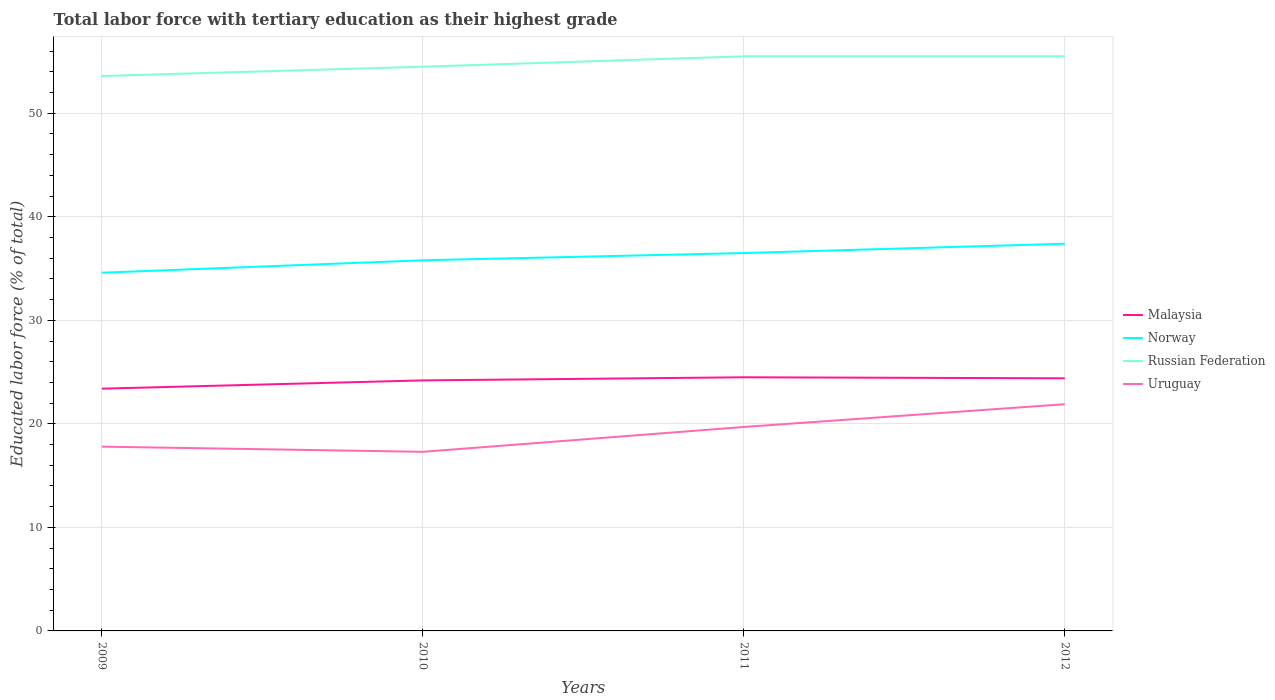Across all years, what is the maximum percentage of male labor force with tertiary education in Norway?
Give a very brief answer. 34.6. In which year was the percentage of male labor force with tertiary education in Malaysia maximum?
Offer a terse response. 2009. What is the total percentage of male labor force with tertiary education in Russian Federation in the graph?
Provide a short and direct response. 0. What is the difference between the highest and the second highest percentage of male labor force with tertiary education in Uruguay?
Offer a terse response. 4.6. How many lines are there?
Offer a very short reply. 4. How many years are there in the graph?
Provide a short and direct response. 4. What is the difference between two consecutive major ticks on the Y-axis?
Your answer should be very brief. 10. Are the values on the major ticks of Y-axis written in scientific E-notation?
Provide a short and direct response. No. Does the graph contain any zero values?
Your answer should be very brief. No. Does the graph contain grids?
Offer a terse response. Yes. Where does the legend appear in the graph?
Your response must be concise. Center right. How many legend labels are there?
Provide a short and direct response. 4. What is the title of the graph?
Your answer should be compact. Total labor force with tertiary education as their highest grade. What is the label or title of the Y-axis?
Make the answer very short. Educated labor force (% of total). What is the Educated labor force (% of total) of Malaysia in 2009?
Keep it short and to the point. 23.4. What is the Educated labor force (% of total) of Norway in 2009?
Offer a terse response. 34.6. What is the Educated labor force (% of total) of Russian Federation in 2009?
Make the answer very short. 53.6. What is the Educated labor force (% of total) in Uruguay in 2009?
Offer a very short reply. 17.8. What is the Educated labor force (% of total) of Malaysia in 2010?
Offer a very short reply. 24.2. What is the Educated labor force (% of total) in Norway in 2010?
Make the answer very short. 35.8. What is the Educated labor force (% of total) in Russian Federation in 2010?
Your response must be concise. 54.5. What is the Educated labor force (% of total) of Uruguay in 2010?
Offer a terse response. 17.3. What is the Educated labor force (% of total) of Malaysia in 2011?
Make the answer very short. 24.5. What is the Educated labor force (% of total) in Norway in 2011?
Make the answer very short. 36.5. What is the Educated labor force (% of total) in Russian Federation in 2011?
Your answer should be compact. 55.5. What is the Educated labor force (% of total) of Uruguay in 2011?
Make the answer very short. 19.7. What is the Educated labor force (% of total) in Malaysia in 2012?
Your response must be concise. 24.4. What is the Educated labor force (% of total) of Norway in 2012?
Provide a short and direct response. 37.4. What is the Educated labor force (% of total) in Russian Federation in 2012?
Make the answer very short. 55.5. What is the Educated labor force (% of total) of Uruguay in 2012?
Offer a terse response. 21.9. Across all years, what is the maximum Educated labor force (% of total) in Malaysia?
Offer a terse response. 24.5. Across all years, what is the maximum Educated labor force (% of total) of Norway?
Keep it short and to the point. 37.4. Across all years, what is the maximum Educated labor force (% of total) in Russian Federation?
Ensure brevity in your answer.  55.5. Across all years, what is the maximum Educated labor force (% of total) of Uruguay?
Your answer should be very brief. 21.9. Across all years, what is the minimum Educated labor force (% of total) in Malaysia?
Give a very brief answer. 23.4. Across all years, what is the minimum Educated labor force (% of total) of Norway?
Provide a succinct answer. 34.6. Across all years, what is the minimum Educated labor force (% of total) in Russian Federation?
Your answer should be compact. 53.6. Across all years, what is the minimum Educated labor force (% of total) in Uruguay?
Provide a succinct answer. 17.3. What is the total Educated labor force (% of total) of Malaysia in the graph?
Your answer should be very brief. 96.5. What is the total Educated labor force (% of total) in Norway in the graph?
Provide a succinct answer. 144.3. What is the total Educated labor force (% of total) of Russian Federation in the graph?
Your answer should be very brief. 219.1. What is the total Educated labor force (% of total) of Uruguay in the graph?
Provide a succinct answer. 76.7. What is the difference between the Educated labor force (% of total) in Russian Federation in 2009 and that in 2010?
Offer a very short reply. -0.9. What is the difference between the Educated labor force (% of total) of Uruguay in 2009 and that in 2010?
Offer a terse response. 0.5. What is the difference between the Educated labor force (% of total) of Malaysia in 2009 and that in 2011?
Your answer should be very brief. -1.1. What is the difference between the Educated labor force (% of total) in Norway in 2009 and that in 2011?
Your answer should be very brief. -1.9. What is the difference between the Educated labor force (% of total) of Uruguay in 2009 and that in 2011?
Make the answer very short. -1.9. What is the difference between the Educated labor force (% of total) in Malaysia in 2010 and that in 2011?
Your answer should be very brief. -0.3. What is the difference between the Educated labor force (% of total) in Norway in 2010 and that in 2011?
Your answer should be compact. -0.7. What is the difference between the Educated labor force (% of total) in Russian Federation in 2010 and that in 2011?
Offer a very short reply. -1. What is the difference between the Educated labor force (% of total) in Malaysia in 2010 and that in 2012?
Give a very brief answer. -0.2. What is the difference between the Educated labor force (% of total) in Uruguay in 2010 and that in 2012?
Provide a succinct answer. -4.6. What is the difference between the Educated labor force (% of total) of Malaysia in 2009 and the Educated labor force (% of total) of Russian Federation in 2010?
Keep it short and to the point. -31.1. What is the difference between the Educated labor force (% of total) in Malaysia in 2009 and the Educated labor force (% of total) in Uruguay in 2010?
Make the answer very short. 6.1. What is the difference between the Educated labor force (% of total) of Norway in 2009 and the Educated labor force (% of total) of Russian Federation in 2010?
Your answer should be compact. -19.9. What is the difference between the Educated labor force (% of total) of Norway in 2009 and the Educated labor force (% of total) of Uruguay in 2010?
Keep it short and to the point. 17.3. What is the difference between the Educated labor force (% of total) of Russian Federation in 2009 and the Educated labor force (% of total) of Uruguay in 2010?
Your response must be concise. 36.3. What is the difference between the Educated labor force (% of total) in Malaysia in 2009 and the Educated labor force (% of total) in Russian Federation in 2011?
Give a very brief answer. -32.1. What is the difference between the Educated labor force (% of total) of Malaysia in 2009 and the Educated labor force (% of total) of Uruguay in 2011?
Your answer should be compact. 3.7. What is the difference between the Educated labor force (% of total) in Norway in 2009 and the Educated labor force (% of total) in Russian Federation in 2011?
Your response must be concise. -20.9. What is the difference between the Educated labor force (% of total) of Norway in 2009 and the Educated labor force (% of total) of Uruguay in 2011?
Give a very brief answer. 14.9. What is the difference between the Educated labor force (% of total) in Russian Federation in 2009 and the Educated labor force (% of total) in Uruguay in 2011?
Make the answer very short. 33.9. What is the difference between the Educated labor force (% of total) in Malaysia in 2009 and the Educated labor force (% of total) in Russian Federation in 2012?
Keep it short and to the point. -32.1. What is the difference between the Educated labor force (% of total) in Malaysia in 2009 and the Educated labor force (% of total) in Uruguay in 2012?
Offer a very short reply. 1.5. What is the difference between the Educated labor force (% of total) in Norway in 2009 and the Educated labor force (% of total) in Russian Federation in 2012?
Your answer should be very brief. -20.9. What is the difference between the Educated labor force (% of total) of Russian Federation in 2009 and the Educated labor force (% of total) of Uruguay in 2012?
Provide a short and direct response. 31.7. What is the difference between the Educated labor force (% of total) of Malaysia in 2010 and the Educated labor force (% of total) of Russian Federation in 2011?
Offer a terse response. -31.3. What is the difference between the Educated labor force (% of total) of Norway in 2010 and the Educated labor force (% of total) of Russian Federation in 2011?
Ensure brevity in your answer.  -19.7. What is the difference between the Educated labor force (% of total) in Norway in 2010 and the Educated labor force (% of total) in Uruguay in 2011?
Your response must be concise. 16.1. What is the difference between the Educated labor force (% of total) in Russian Federation in 2010 and the Educated labor force (% of total) in Uruguay in 2011?
Offer a terse response. 34.8. What is the difference between the Educated labor force (% of total) of Malaysia in 2010 and the Educated labor force (% of total) of Russian Federation in 2012?
Your answer should be compact. -31.3. What is the difference between the Educated labor force (% of total) of Norway in 2010 and the Educated labor force (% of total) of Russian Federation in 2012?
Provide a succinct answer. -19.7. What is the difference between the Educated labor force (% of total) of Russian Federation in 2010 and the Educated labor force (% of total) of Uruguay in 2012?
Provide a short and direct response. 32.6. What is the difference between the Educated labor force (% of total) in Malaysia in 2011 and the Educated labor force (% of total) in Russian Federation in 2012?
Offer a very short reply. -31. What is the difference between the Educated labor force (% of total) in Norway in 2011 and the Educated labor force (% of total) in Russian Federation in 2012?
Provide a succinct answer. -19. What is the difference between the Educated labor force (% of total) of Russian Federation in 2011 and the Educated labor force (% of total) of Uruguay in 2012?
Offer a very short reply. 33.6. What is the average Educated labor force (% of total) in Malaysia per year?
Provide a short and direct response. 24.12. What is the average Educated labor force (% of total) of Norway per year?
Give a very brief answer. 36.08. What is the average Educated labor force (% of total) of Russian Federation per year?
Provide a short and direct response. 54.77. What is the average Educated labor force (% of total) in Uruguay per year?
Provide a short and direct response. 19.18. In the year 2009, what is the difference between the Educated labor force (% of total) in Malaysia and Educated labor force (% of total) in Norway?
Give a very brief answer. -11.2. In the year 2009, what is the difference between the Educated labor force (% of total) of Malaysia and Educated labor force (% of total) of Russian Federation?
Provide a succinct answer. -30.2. In the year 2009, what is the difference between the Educated labor force (% of total) of Russian Federation and Educated labor force (% of total) of Uruguay?
Provide a short and direct response. 35.8. In the year 2010, what is the difference between the Educated labor force (% of total) in Malaysia and Educated labor force (% of total) in Russian Federation?
Make the answer very short. -30.3. In the year 2010, what is the difference between the Educated labor force (% of total) of Malaysia and Educated labor force (% of total) of Uruguay?
Ensure brevity in your answer.  6.9. In the year 2010, what is the difference between the Educated labor force (% of total) in Norway and Educated labor force (% of total) in Russian Federation?
Give a very brief answer. -18.7. In the year 2010, what is the difference between the Educated labor force (% of total) of Russian Federation and Educated labor force (% of total) of Uruguay?
Offer a very short reply. 37.2. In the year 2011, what is the difference between the Educated labor force (% of total) of Malaysia and Educated labor force (% of total) of Norway?
Ensure brevity in your answer.  -12. In the year 2011, what is the difference between the Educated labor force (% of total) of Malaysia and Educated labor force (% of total) of Russian Federation?
Make the answer very short. -31. In the year 2011, what is the difference between the Educated labor force (% of total) in Malaysia and Educated labor force (% of total) in Uruguay?
Offer a very short reply. 4.8. In the year 2011, what is the difference between the Educated labor force (% of total) in Russian Federation and Educated labor force (% of total) in Uruguay?
Provide a short and direct response. 35.8. In the year 2012, what is the difference between the Educated labor force (% of total) of Malaysia and Educated labor force (% of total) of Russian Federation?
Your response must be concise. -31.1. In the year 2012, what is the difference between the Educated labor force (% of total) of Malaysia and Educated labor force (% of total) of Uruguay?
Your answer should be compact. 2.5. In the year 2012, what is the difference between the Educated labor force (% of total) of Norway and Educated labor force (% of total) of Russian Federation?
Offer a terse response. -18.1. In the year 2012, what is the difference between the Educated labor force (% of total) in Russian Federation and Educated labor force (% of total) in Uruguay?
Offer a very short reply. 33.6. What is the ratio of the Educated labor force (% of total) of Malaysia in 2009 to that in 2010?
Offer a terse response. 0.97. What is the ratio of the Educated labor force (% of total) in Norway in 2009 to that in 2010?
Your response must be concise. 0.97. What is the ratio of the Educated labor force (% of total) in Russian Federation in 2009 to that in 2010?
Your answer should be compact. 0.98. What is the ratio of the Educated labor force (% of total) of Uruguay in 2009 to that in 2010?
Give a very brief answer. 1.03. What is the ratio of the Educated labor force (% of total) of Malaysia in 2009 to that in 2011?
Offer a terse response. 0.96. What is the ratio of the Educated labor force (% of total) in Norway in 2009 to that in 2011?
Keep it short and to the point. 0.95. What is the ratio of the Educated labor force (% of total) in Russian Federation in 2009 to that in 2011?
Your response must be concise. 0.97. What is the ratio of the Educated labor force (% of total) of Uruguay in 2009 to that in 2011?
Keep it short and to the point. 0.9. What is the ratio of the Educated labor force (% of total) in Norway in 2009 to that in 2012?
Your response must be concise. 0.93. What is the ratio of the Educated labor force (% of total) in Russian Federation in 2009 to that in 2012?
Offer a terse response. 0.97. What is the ratio of the Educated labor force (% of total) in Uruguay in 2009 to that in 2012?
Make the answer very short. 0.81. What is the ratio of the Educated labor force (% of total) in Norway in 2010 to that in 2011?
Give a very brief answer. 0.98. What is the ratio of the Educated labor force (% of total) in Russian Federation in 2010 to that in 2011?
Your response must be concise. 0.98. What is the ratio of the Educated labor force (% of total) in Uruguay in 2010 to that in 2011?
Your response must be concise. 0.88. What is the ratio of the Educated labor force (% of total) of Malaysia in 2010 to that in 2012?
Give a very brief answer. 0.99. What is the ratio of the Educated labor force (% of total) in Norway in 2010 to that in 2012?
Your answer should be compact. 0.96. What is the ratio of the Educated labor force (% of total) of Russian Federation in 2010 to that in 2012?
Give a very brief answer. 0.98. What is the ratio of the Educated labor force (% of total) of Uruguay in 2010 to that in 2012?
Your answer should be compact. 0.79. What is the ratio of the Educated labor force (% of total) in Norway in 2011 to that in 2012?
Make the answer very short. 0.98. What is the ratio of the Educated labor force (% of total) of Russian Federation in 2011 to that in 2012?
Provide a succinct answer. 1. What is the ratio of the Educated labor force (% of total) of Uruguay in 2011 to that in 2012?
Your answer should be very brief. 0.9. What is the difference between the highest and the second highest Educated labor force (% of total) of Malaysia?
Keep it short and to the point. 0.1. What is the difference between the highest and the second highest Educated labor force (% of total) in Russian Federation?
Your answer should be compact. 0. What is the difference between the highest and the second highest Educated labor force (% of total) in Uruguay?
Your answer should be very brief. 2.2. 